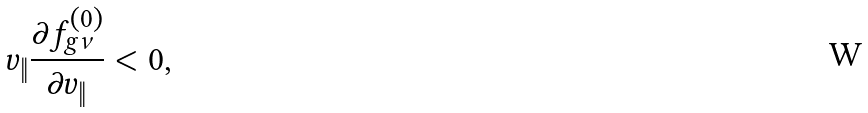<formula> <loc_0><loc_0><loc_500><loc_500>v _ { \| } \frac { \partial f ^ { ( 0 ) } _ { g \nu } } { \partial v _ { \| } } < 0 ,</formula> 